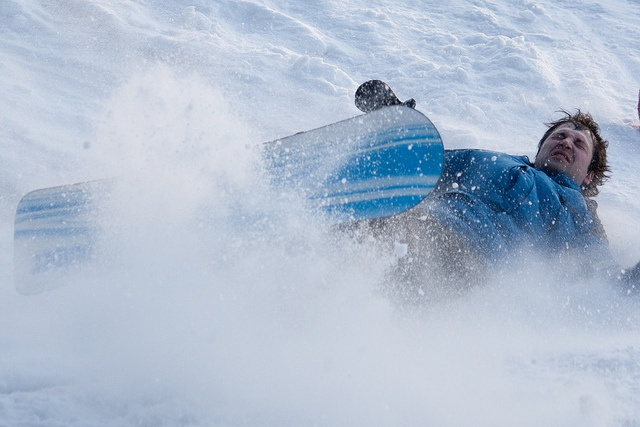Describe the objects in this image and their specific colors. I can see snowboard in darkgray, lightgray, and gray tones and people in darkgray, gray, and blue tones in this image. 